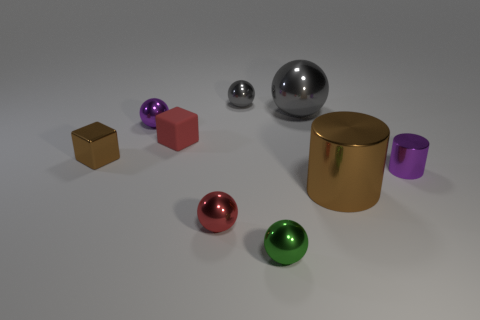What color is the tiny shiny object that is in front of the small shiny block and behind the big brown metal thing? purple 